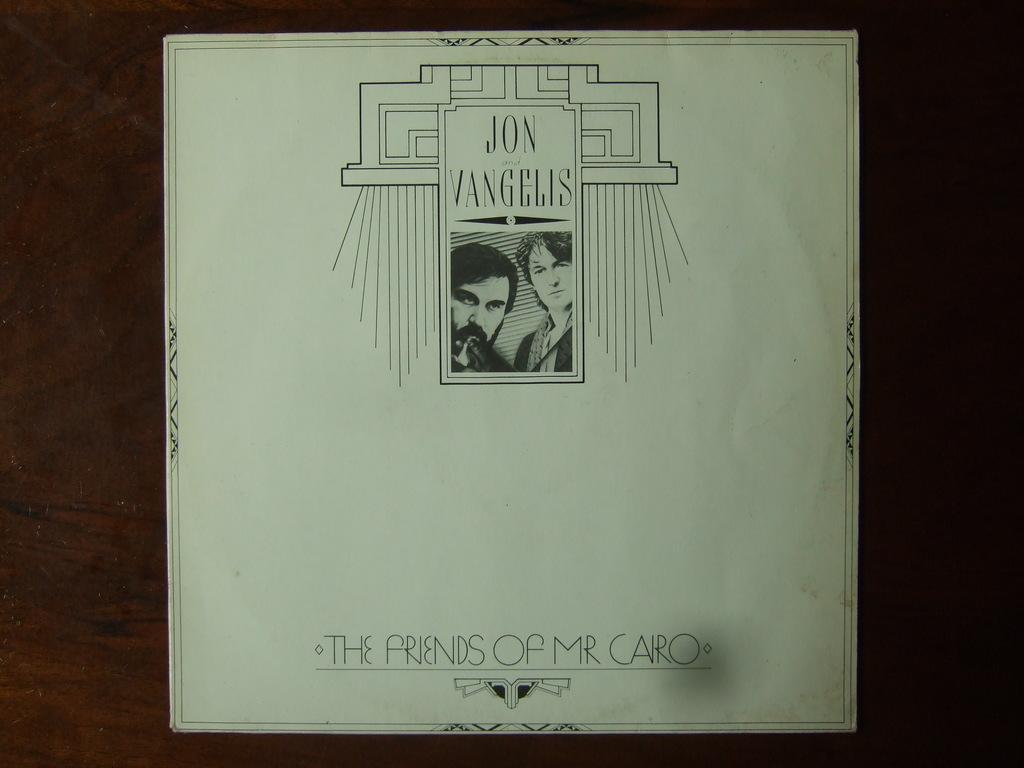What is present on the table in the image? There is a paper on the table in the image. What can be seen on the paper? The paper has pictures of people on it and text on it. What type of power is being generated by the people in the images on the paper? There is no indication in the image that the people in the images on the paper are generating any power. 